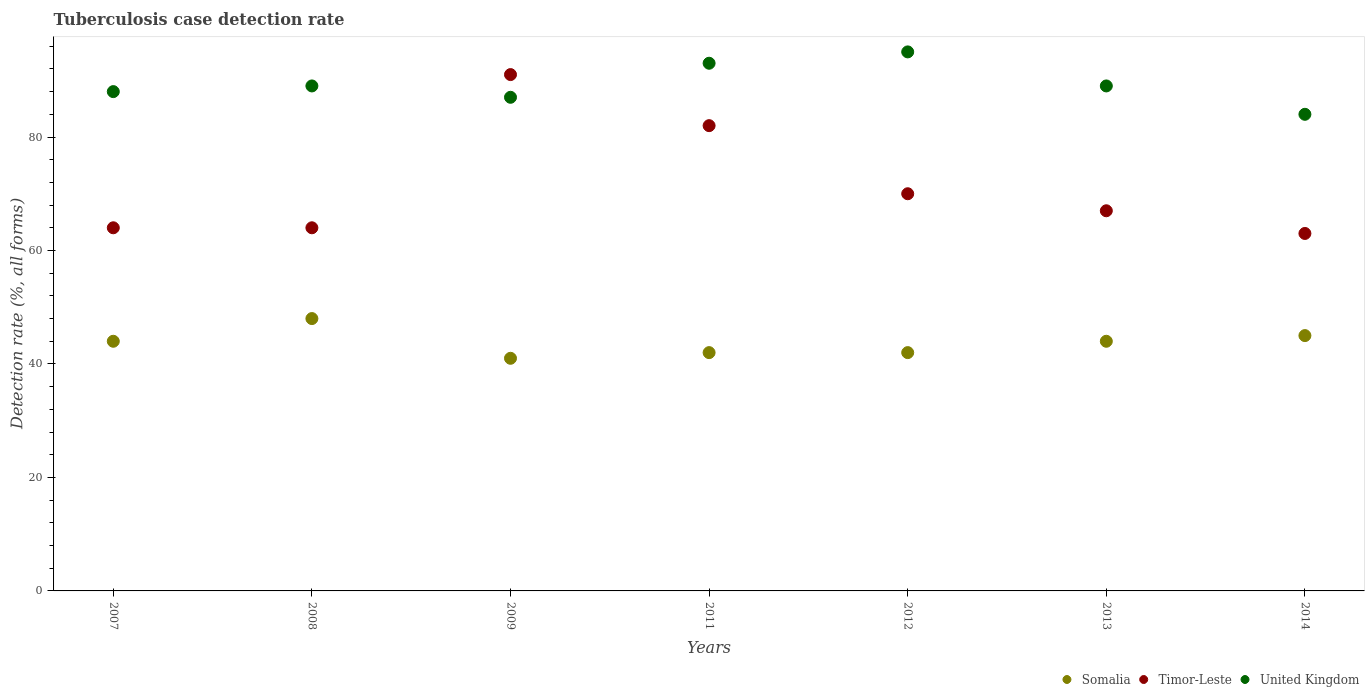How many different coloured dotlines are there?
Your response must be concise. 3. What is the tuberculosis case detection rate in in Somalia in 2012?
Make the answer very short. 42. Across all years, what is the maximum tuberculosis case detection rate in in United Kingdom?
Give a very brief answer. 95. In which year was the tuberculosis case detection rate in in United Kingdom minimum?
Give a very brief answer. 2014. What is the total tuberculosis case detection rate in in Timor-Leste in the graph?
Keep it short and to the point. 501. What is the difference between the tuberculosis case detection rate in in Timor-Leste in 2009 and that in 2012?
Ensure brevity in your answer.  21. What is the difference between the tuberculosis case detection rate in in United Kingdom in 2012 and the tuberculosis case detection rate in in Timor-Leste in 2009?
Keep it short and to the point. 4. What is the average tuberculosis case detection rate in in Somalia per year?
Your answer should be very brief. 43.71. In the year 2007, what is the difference between the tuberculosis case detection rate in in Timor-Leste and tuberculosis case detection rate in in United Kingdom?
Provide a short and direct response. -24. In how many years, is the tuberculosis case detection rate in in Timor-Leste greater than 76 %?
Your response must be concise. 2. What is the ratio of the tuberculosis case detection rate in in Timor-Leste in 2007 to that in 2014?
Offer a terse response. 1.02. Is the tuberculosis case detection rate in in Timor-Leste in 2012 less than that in 2013?
Provide a short and direct response. No. Is the difference between the tuberculosis case detection rate in in Timor-Leste in 2008 and 2014 greater than the difference between the tuberculosis case detection rate in in United Kingdom in 2008 and 2014?
Provide a short and direct response. No. In how many years, is the tuberculosis case detection rate in in Somalia greater than the average tuberculosis case detection rate in in Somalia taken over all years?
Your response must be concise. 4. Is the tuberculosis case detection rate in in Timor-Leste strictly greater than the tuberculosis case detection rate in in United Kingdom over the years?
Offer a terse response. No. Is the tuberculosis case detection rate in in United Kingdom strictly less than the tuberculosis case detection rate in in Somalia over the years?
Your response must be concise. No. How many dotlines are there?
Provide a succinct answer. 3. How many years are there in the graph?
Offer a terse response. 7. Does the graph contain grids?
Keep it short and to the point. No. How are the legend labels stacked?
Offer a very short reply. Horizontal. What is the title of the graph?
Ensure brevity in your answer.  Tuberculosis case detection rate. Does "Middle East & North Africa (developing only)" appear as one of the legend labels in the graph?
Ensure brevity in your answer.  No. What is the label or title of the Y-axis?
Make the answer very short. Detection rate (%, all forms). What is the Detection rate (%, all forms) of United Kingdom in 2007?
Your response must be concise. 88. What is the Detection rate (%, all forms) in Timor-Leste in 2008?
Provide a short and direct response. 64. What is the Detection rate (%, all forms) in United Kingdom in 2008?
Ensure brevity in your answer.  89. What is the Detection rate (%, all forms) of Timor-Leste in 2009?
Your answer should be very brief. 91. What is the Detection rate (%, all forms) in Somalia in 2011?
Offer a very short reply. 42. What is the Detection rate (%, all forms) in United Kingdom in 2011?
Your response must be concise. 93. What is the Detection rate (%, all forms) of Somalia in 2012?
Your response must be concise. 42. What is the Detection rate (%, all forms) of Somalia in 2013?
Ensure brevity in your answer.  44. What is the Detection rate (%, all forms) in Timor-Leste in 2013?
Provide a succinct answer. 67. What is the Detection rate (%, all forms) in United Kingdom in 2013?
Make the answer very short. 89. What is the Detection rate (%, all forms) in Timor-Leste in 2014?
Your answer should be compact. 63. Across all years, what is the maximum Detection rate (%, all forms) of Timor-Leste?
Your response must be concise. 91. Across all years, what is the minimum Detection rate (%, all forms) of Somalia?
Offer a very short reply. 41. Across all years, what is the minimum Detection rate (%, all forms) of Timor-Leste?
Offer a terse response. 63. Across all years, what is the minimum Detection rate (%, all forms) of United Kingdom?
Ensure brevity in your answer.  84. What is the total Detection rate (%, all forms) in Somalia in the graph?
Your answer should be compact. 306. What is the total Detection rate (%, all forms) of Timor-Leste in the graph?
Give a very brief answer. 501. What is the total Detection rate (%, all forms) in United Kingdom in the graph?
Make the answer very short. 625. What is the difference between the Detection rate (%, all forms) of Somalia in 2007 and that in 2008?
Offer a very short reply. -4. What is the difference between the Detection rate (%, all forms) in Timor-Leste in 2007 and that in 2008?
Offer a terse response. 0. What is the difference between the Detection rate (%, all forms) of Somalia in 2007 and that in 2009?
Provide a short and direct response. 3. What is the difference between the Detection rate (%, all forms) of Somalia in 2007 and that in 2011?
Provide a succinct answer. 2. What is the difference between the Detection rate (%, all forms) of Timor-Leste in 2007 and that in 2011?
Offer a very short reply. -18. What is the difference between the Detection rate (%, all forms) in Timor-Leste in 2007 and that in 2012?
Your answer should be very brief. -6. What is the difference between the Detection rate (%, all forms) of United Kingdom in 2007 and that in 2012?
Your answer should be very brief. -7. What is the difference between the Detection rate (%, all forms) of Somalia in 2007 and that in 2013?
Your response must be concise. 0. What is the difference between the Detection rate (%, all forms) of Timor-Leste in 2007 and that in 2013?
Your answer should be compact. -3. What is the difference between the Detection rate (%, all forms) in Somalia in 2007 and that in 2014?
Keep it short and to the point. -1. What is the difference between the Detection rate (%, all forms) in Timor-Leste in 2007 and that in 2014?
Your answer should be compact. 1. What is the difference between the Detection rate (%, all forms) of Somalia in 2008 and that in 2009?
Offer a very short reply. 7. What is the difference between the Detection rate (%, all forms) of United Kingdom in 2008 and that in 2009?
Keep it short and to the point. 2. What is the difference between the Detection rate (%, all forms) of Somalia in 2008 and that in 2012?
Ensure brevity in your answer.  6. What is the difference between the Detection rate (%, all forms) in United Kingdom in 2008 and that in 2012?
Offer a very short reply. -6. What is the difference between the Detection rate (%, all forms) of Somalia in 2008 and that in 2013?
Offer a terse response. 4. What is the difference between the Detection rate (%, all forms) in United Kingdom in 2008 and that in 2013?
Keep it short and to the point. 0. What is the difference between the Detection rate (%, all forms) of Somalia in 2009 and that in 2011?
Offer a very short reply. -1. What is the difference between the Detection rate (%, all forms) of United Kingdom in 2009 and that in 2011?
Make the answer very short. -6. What is the difference between the Detection rate (%, all forms) in Timor-Leste in 2009 and that in 2012?
Your response must be concise. 21. What is the difference between the Detection rate (%, all forms) in United Kingdom in 2009 and that in 2013?
Your response must be concise. -2. What is the difference between the Detection rate (%, all forms) of Timor-Leste in 2009 and that in 2014?
Offer a terse response. 28. What is the difference between the Detection rate (%, all forms) in Somalia in 2011 and that in 2012?
Your response must be concise. 0. What is the difference between the Detection rate (%, all forms) of Timor-Leste in 2011 and that in 2012?
Offer a very short reply. 12. What is the difference between the Detection rate (%, all forms) in United Kingdom in 2011 and that in 2012?
Offer a terse response. -2. What is the difference between the Detection rate (%, all forms) of United Kingdom in 2011 and that in 2013?
Your response must be concise. 4. What is the difference between the Detection rate (%, all forms) of Somalia in 2011 and that in 2014?
Make the answer very short. -3. What is the difference between the Detection rate (%, all forms) in Timor-Leste in 2011 and that in 2014?
Your answer should be very brief. 19. What is the difference between the Detection rate (%, all forms) in United Kingdom in 2011 and that in 2014?
Keep it short and to the point. 9. What is the difference between the Detection rate (%, all forms) in Somalia in 2012 and that in 2013?
Provide a succinct answer. -2. What is the difference between the Detection rate (%, all forms) of Timor-Leste in 2012 and that in 2013?
Make the answer very short. 3. What is the difference between the Detection rate (%, all forms) in United Kingdom in 2012 and that in 2013?
Offer a very short reply. 6. What is the difference between the Detection rate (%, all forms) of Timor-Leste in 2012 and that in 2014?
Make the answer very short. 7. What is the difference between the Detection rate (%, all forms) of Somalia in 2013 and that in 2014?
Offer a terse response. -1. What is the difference between the Detection rate (%, all forms) of Timor-Leste in 2013 and that in 2014?
Offer a terse response. 4. What is the difference between the Detection rate (%, all forms) of Somalia in 2007 and the Detection rate (%, all forms) of Timor-Leste in 2008?
Your response must be concise. -20. What is the difference between the Detection rate (%, all forms) in Somalia in 2007 and the Detection rate (%, all forms) in United Kingdom in 2008?
Offer a very short reply. -45. What is the difference between the Detection rate (%, all forms) in Somalia in 2007 and the Detection rate (%, all forms) in Timor-Leste in 2009?
Your answer should be very brief. -47. What is the difference between the Detection rate (%, all forms) in Somalia in 2007 and the Detection rate (%, all forms) in United Kingdom in 2009?
Your answer should be very brief. -43. What is the difference between the Detection rate (%, all forms) of Timor-Leste in 2007 and the Detection rate (%, all forms) of United Kingdom in 2009?
Give a very brief answer. -23. What is the difference between the Detection rate (%, all forms) of Somalia in 2007 and the Detection rate (%, all forms) of Timor-Leste in 2011?
Offer a terse response. -38. What is the difference between the Detection rate (%, all forms) of Somalia in 2007 and the Detection rate (%, all forms) of United Kingdom in 2011?
Provide a succinct answer. -49. What is the difference between the Detection rate (%, all forms) in Timor-Leste in 2007 and the Detection rate (%, all forms) in United Kingdom in 2011?
Provide a succinct answer. -29. What is the difference between the Detection rate (%, all forms) of Somalia in 2007 and the Detection rate (%, all forms) of Timor-Leste in 2012?
Make the answer very short. -26. What is the difference between the Detection rate (%, all forms) of Somalia in 2007 and the Detection rate (%, all forms) of United Kingdom in 2012?
Your answer should be very brief. -51. What is the difference between the Detection rate (%, all forms) in Timor-Leste in 2007 and the Detection rate (%, all forms) in United Kingdom in 2012?
Your answer should be very brief. -31. What is the difference between the Detection rate (%, all forms) in Somalia in 2007 and the Detection rate (%, all forms) in United Kingdom in 2013?
Ensure brevity in your answer.  -45. What is the difference between the Detection rate (%, all forms) in Somalia in 2007 and the Detection rate (%, all forms) in United Kingdom in 2014?
Offer a terse response. -40. What is the difference between the Detection rate (%, all forms) in Timor-Leste in 2007 and the Detection rate (%, all forms) in United Kingdom in 2014?
Ensure brevity in your answer.  -20. What is the difference between the Detection rate (%, all forms) of Somalia in 2008 and the Detection rate (%, all forms) of Timor-Leste in 2009?
Offer a terse response. -43. What is the difference between the Detection rate (%, all forms) in Somalia in 2008 and the Detection rate (%, all forms) in United Kingdom in 2009?
Ensure brevity in your answer.  -39. What is the difference between the Detection rate (%, all forms) in Somalia in 2008 and the Detection rate (%, all forms) in Timor-Leste in 2011?
Your answer should be compact. -34. What is the difference between the Detection rate (%, all forms) of Somalia in 2008 and the Detection rate (%, all forms) of United Kingdom in 2011?
Offer a terse response. -45. What is the difference between the Detection rate (%, all forms) in Timor-Leste in 2008 and the Detection rate (%, all forms) in United Kingdom in 2011?
Offer a very short reply. -29. What is the difference between the Detection rate (%, all forms) in Somalia in 2008 and the Detection rate (%, all forms) in Timor-Leste in 2012?
Ensure brevity in your answer.  -22. What is the difference between the Detection rate (%, all forms) of Somalia in 2008 and the Detection rate (%, all forms) of United Kingdom in 2012?
Offer a terse response. -47. What is the difference between the Detection rate (%, all forms) of Timor-Leste in 2008 and the Detection rate (%, all forms) of United Kingdom in 2012?
Your answer should be very brief. -31. What is the difference between the Detection rate (%, all forms) in Somalia in 2008 and the Detection rate (%, all forms) in United Kingdom in 2013?
Offer a very short reply. -41. What is the difference between the Detection rate (%, all forms) of Timor-Leste in 2008 and the Detection rate (%, all forms) of United Kingdom in 2013?
Offer a terse response. -25. What is the difference between the Detection rate (%, all forms) of Somalia in 2008 and the Detection rate (%, all forms) of United Kingdom in 2014?
Your answer should be very brief. -36. What is the difference between the Detection rate (%, all forms) of Somalia in 2009 and the Detection rate (%, all forms) of Timor-Leste in 2011?
Your answer should be compact. -41. What is the difference between the Detection rate (%, all forms) of Somalia in 2009 and the Detection rate (%, all forms) of United Kingdom in 2011?
Offer a very short reply. -52. What is the difference between the Detection rate (%, all forms) of Somalia in 2009 and the Detection rate (%, all forms) of Timor-Leste in 2012?
Offer a terse response. -29. What is the difference between the Detection rate (%, all forms) in Somalia in 2009 and the Detection rate (%, all forms) in United Kingdom in 2012?
Give a very brief answer. -54. What is the difference between the Detection rate (%, all forms) of Somalia in 2009 and the Detection rate (%, all forms) of Timor-Leste in 2013?
Ensure brevity in your answer.  -26. What is the difference between the Detection rate (%, all forms) in Somalia in 2009 and the Detection rate (%, all forms) in United Kingdom in 2013?
Ensure brevity in your answer.  -48. What is the difference between the Detection rate (%, all forms) of Timor-Leste in 2009 and the Detection rate (%, all forms) of United Kingdom in 2013?
Provide a succinct answer. 2. What is the difference between the Detection rate (%, all forms) of Somalia in 2009 and the Detection rate (%, all forms) of Timor-Leste in 2014?
Provide a succinct answer. -22. What is the difference between the Detection rate (%, all forms) in Somalia in 2009 and the Detection rate (%, all forms) in United Kingdom in 2014?
Ensure brevity in your answer.  -43. What is the difference between the Detection rate (%, all forms) of Somalia in 2011 and the Detection rate (%, all forms) of Timor-Leste in 2012?
Your answer should be compact. -28. What is the difference between the Detection rate (%, all forms) of Somalia in 2011 and the Detection rate (%, all forms) of United Kingdom in 2012?
Your response must be concise. -53. What is the difference between the Detection rate (%, all forms) of Timor-Leste in 2011 and the Detection rate (%, all forms) of United Kingdom in 2012?
Ensure brevity in your answer.  -13. What is the difference between the Detection rate (%, all forms) in Somalia in 2011 and the Detection rate (%, all forms) in United Kingdom in 2013?
Make the answer very short. -47. What is the difference between the Detection rate (%, all forms) of Somalia in 2011 and the Detection rate (%, all forms) of United Kingdom in 2014?
Your response must be concise. -42. What is the difference between the Detection rate (%, all forms) in Somalia in 2012 and the Detection rate (%, all forms) in United Kingdom in 2013?
Your answer should be compact. -47. What is the difference between the Detection rate (%, all forms) of Timor-Leste in 2012 and the Detection rate (%, all forms) of United Kingdom in 2013?
Keep it short and to the point. -19. What is the difference between the Detection rate (%, all forms) in Somalia in 2012 and the Detection rate (%, all forms) in Timor-Leste in 2014?
Keep it short and to the point. -21. What is the difference between the Detection rate (%, all forms) in Somalia in 2012 and the Detection rate (%, all forms) in United Kingdom in 2014?
Ensure brevity in your answer.  -42. What is the difference between the Detection rate (%, all forms) of Somalia in 2013 and the Detection rate (%, all forms) of Timor-Leste in 2014?
Keep it short and to the point. -19. What is the difference between the Detection rate (%, all forms) of Timor-Leste in 2013 and the Detection rate (%, all forms) of United Kingdom in 2014?
Your answer should be very brief. -17. What is the average Detection rate (%, all forms) of Somalia per year?
Provide a short and direct response. 43.71. What is the average Detection rate (%, all forms) of Timor-Leste per year?
Give a very brief answer. 71.57. What is the average Detection rate (%, all forms) of United Kingdom per year?
Offer a very short reply. 89.29. In the year 2007, what is the difference between the Detection rate (%, all forms) in Somalia and Detection rate (%, all forms) in United Kingdom?
Provide a succinct answer. -44. In the year 2008, what is the difference between the Detection rate (%, all forms) in Somalia and Detection rate (%, all forms) in United Kingdom?
Your answer should be compact. -41. In the year 2009, what is the difference between the Detection rate (%, all forms) in Somalia and Detection rate (%, all forms) in Timor-Leste?
Ensure brevity in your answer.  -50. In the year 2009, what is the difference between the Detection rate (%, all forms) of Somalia and Detection rate (%, all forms) of United Kingdom?
Offer a very short reply. -46. In the year 2009, what is the difference between the Detection rate (%, all forms) of Timor-Leste and Detection rate (%, all forms) of United Kingdom?
Provide a succinct answer. 4. In the year 2011, what is the difference between the Detection rate (%, all forms) in Somalia and Detection rate (%, all forms) in Timor-Leste?
Provide a succinct answer. -40. In the year 2011, what is the difference between the Detection rate (%, all forms) of Somalia and Detection rate (%, all forms) of United Kingdom?
Your answer should be compact. -51. In the year 2012, what is the difference between the Detection rate (%, all forms) of Somalia and Detection rate (%, all forms) of Timor-Leste?
Offer a very short reply. -28. In the year 2012, what is the difference between the Detection rate (%, all forms) in Somalia and Detection rate (%, all forms) in United Kingdom?
Offer a very short reply. -53. In the year 2013, what is the difference between the Detection rate (%, all forms) of Somalia and Detection rate (%, all forms) of United Kingdom?
Give a very brief answer. -45. In the year 2014, what is the difference between the Detection rate (%, all forms) in Somalia and Detection rate (%, all forms) in United Kingdom?
Your answer should be compact. -39. In the year 2014, what is the difference between the Detection rate (%, all forms) of Timor-Leste and Detection rate (%, all forms) of United Kingdom?
Give a very brief answer. -21. What is the ratio of the Detection rate (%, all forms) in Timor-Leste in 2007 to that in 2008?
Keep it short and to the point. 1. What is the ratio of the Detection rate (%, all forms) of Somalia in 2007 to that in 2009?
Your response must be concise. 1.07. What is the ratio of the Detection rate (%, all forms) in Timor-Leste in 2007 to that in 2009?
Your answer should be compact. 0.7. What is the ratio of the Detection rate (%, all forms) of United Kingdom in 2007 to that in 2009?
Keep it short and to the point. 1.01. What is the ratio of the Detection rate (%, all forms) of Somalia in 2007 to that in 2011?
Offer a terse response. 1.05. What is the ratio of the Detection rate (%, all forms) in Timor-Leste in 2007 to that in 2011?
Offer a very short reply. 0.78. What is the ratio of the Detection rate (%, all forms) in United Kingdom in 2007 to that in 2011?
Your response must be concise. 0.95. What is the ratio of the Detection rate (%, all forms) in Somalia in 2007 to that in 2012?
Provide a short and direct response. 1.05. What is the ratio of the Detection rate (%, all forms) in Timor-Leste in 2007 to that in 2012?
Offer a very short reply. 0.91. What is the ratio of the Detection rate (%, all forms) of United Kingdom in 2007 to that in 2012?
Provide a succinct answer. 0.93. What is the ratio of the Detection rate (%, all forms) in Somalia in 2007 to that in 2013?
Provide a succinct answer. 1. What is the ratio of the Detection rate (%, all forms) of Timor-Leste in 2007 to that in 2013?
Your answer should be compact. 0.96. What is the ratio of the Detection rate (%, all forms) in Somalia in 2007 to that in 2014?
Your answer should be compact. 0.98. What is the ratio of the Detection rate (%, all forms) in Timor-Leste in 2007 to that in 2014?
Provide a short and direct response. 1.02. What is the ratio of the Detection rate (%, all forms) of United Kingdom in 2007 to that in 2014?
Your response must be concise. 1.05. What is the ratio of the Detection rate (%, all forms) of Somalia in 2008 to that in 2009?
Ensure brevity in your answer.  1.17. What is the ratio of the Detection rate (%, all forms) of Timor-Leste in 2008 to that in 2009?
Make the answer very short. 0.7. What is the ratio of the Detection rate (%, all forms) in United Kingdom in 2008 to that in 2009?
Your answer should be very brief. 1.02. What is the ratio of the Detection rate (%, all forms) of Somalia in 2008 to that in 2011?
Offer a terse response. 1.14. What is the ratio of the Detection rate (%, all forms) of Timor-Leste in 2008 to that in 2011?
Offer a terse response. 0.78. What is the ratio of the Detection rate (%, all forms) in Somalia in 2008 to that in 2012?
Keep it short and to the point. 1.14. What is the ratio of the Detection rate (%, all forms) in Timor-Leste in 2008 to that in 2012?
Your answer should be compact. 0.91. What is the ratio of the Detection rate (%, all forms) of United Kingdom in 2008 to that in 2012?
Your answer should be very brief. 0.94. What is the ratio of the Detection rate (%, all forms) in Somalia in 2008 to that in 2013?
Provide a short and direct response. 1.09. What is the ratio of the Detection rate (%, all forms) in Timor-Leste in 2008 to that in 2013?
Offer a terse response. 0.96. What is the ratio of the Detection rate (%, all forms) of United Kingdom in 2008 to that in 2013?
Give a very brief answer. 1. What is the ratio of the Detection rate (%, all forms) in Somalia in 2008 to that in 2014?
Ensure brevity in your answer.  1.07. What is the ratio of the Detection rate (%, all forms) of Timor-Leste in 2008 to that in 2014?
Give a very brief answer. 1.02. What is the ratio of the Detection rate (%, all forms) of United Kingdom in 2008 to that in 2014?
Your response must be concise. 1.06. What is the ratio of the Detection rate (%, all forms) of Somalia in 2009 to that in 2011?
Your answer should be compact. 0.98. What is the ratio of the Detection rate (%, all forms) of Timor-Leste in 2009 to that in 2011?
Your answer should be very brief. 1.11. What is the ratio of the Detection rate (%, all forms) of United Kingdom in 2009 to that in 2011?
Ensure brevity in your answer.  0.94. What is the ratio of the Detection rate (%, all forms) in Somalia in 2009 to that in 2012?
Offer a very short reply. 0.98. What is the ratio of the Detection rate (%, all forms) in United Kingdom in 2009 to that in 2012?
Offer a very short reply. 0.92. What is the ratio of the Detection rate (%, all forms) of Somalia in 2009 to that in 2013?
Your answer should be compact. 0.93. What is the ratio of the Detection rate (%, all forms) in Timor-Leste in 2009 to that in 2013?
Give a very brief answer. 1.36. What is the ratio of the Detection rate (%, all forms) of United Kingdom in 2009 to that in 2013?
Your answer should be very brief. 0.98. What is the ratio of the Detection rate (%, all forms) in Somalia in 2009 to that in 2014?
Ensure brevity in your answer.  0.91. What is the ratio of the Detection rate (%, all forms) of Timor-Leste in 2009 to that in 2014?
Ensure brevity in your answer.  1.44. What is the ratio of the Detection rate (%, all forms) of United Kingdom in 2009 to that in 2014?
Your response must be concise. 1.04. What is the ratio of the Detection rate (%, all forms) in Timor-Leste in 2011 to that in 2012?
Provide a succinct answer. 1.17. What is the ratio of the Detection rate (%, all forms) of United Kingdom in 2011 to that in 2012?
Provide a succinct answer. 0.98. What is the ratio of the Detection rate (%, all forms) of Somalia in 2011 to that in 2013?
Your response must be concise. 0.95. What is the ratio of the Detection rate (%, all forms) in Timor-Leste in 2011 to that in 2013?
Ensure brevity in your answer.  1.22. What is the ratio of the Detection rate (%, all forms) of United Kingdom in 2011 to that in 2013?
Ensure brevity in your answer.  1.04. What is the ratio of the Detection rate (%, all forms) in Somalia in 2011 to that in 2014?
Ensure brevity in your answer.  0.93. What is the ratio of the Detection rate (%, all forms) in Timor-Leste in 2011 to that in 2014?
Ensure brevity in your answer.  1.3. What is the ratio of the Detection rate (%, all forms) of United Kingdom in 2011 to that in 2014?
Make the answer very short. 1.11. What is the ratio of the Detection rate (%, all forms) in Somalia in 2012 to that in 2013?
Your answer should be very brief. 0.95. What is the ratio of the Detection rate (%, all forms) in Timor-Leste in 2012 to that in 2013?
Offer a very short reply. 1.04. What is the ratio of the Detection rate (%, all forms) of United Kingdom in 2012 to that in 2013?
Provide a succinct answer. 1.07. What is the ratio of the Detection rate (%, all forms) of Somalia in 2012 to that in 2014?
Provide a succinct answer. 0.93. What is the ratio of the Detection rate (%, all forms) in Timor-Leste in 2012 to that in 2014?
Your answer should be compact. 1.11. What is the ratio of the Detection rate (%, all forms) of United Kingdom in 2012 to that in 2014?
Your response must be concise. 1.13. What is the ratio of the Detection rate (%, all forms) of Somalia in 2013 to that in 2014?
Your answer should be very brief. 0.98. What is the ratio of the Detection rate (%, all forms) of Timor-Leste in 2013 to that in 2014?
Your answer should be compact. 1.06. What is the ratio of the Detection rate (%, all forms) in United Kingdom in 2013 to that in 2014?
Your response must be concise. 1.06. What is the difference between the highest and the lowest Detection rate (%, all forms) in Somalia?
Your answer should be very brief. 7. What is the difference between the highest and the lowest Detection rate (%, all forms) of United Kingdom?
Offer a very short reply. 11. 